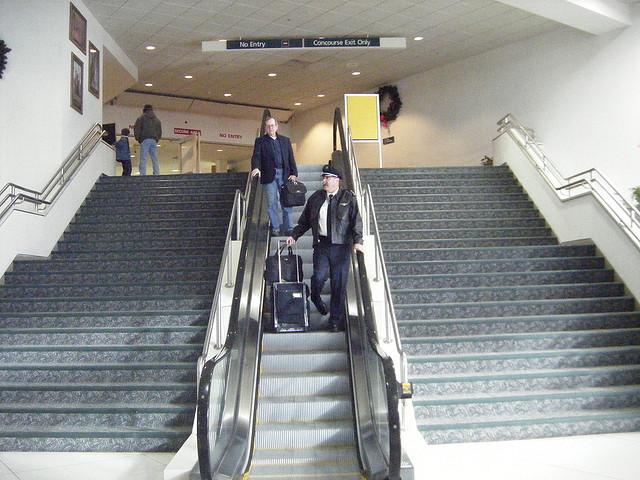Are these people going up or down?
Be succinct. Down. What decoration is hanging on the wall?
Give a very brief answer. Wreath. Is the stairway crowded?
Write a very short answer. No. 